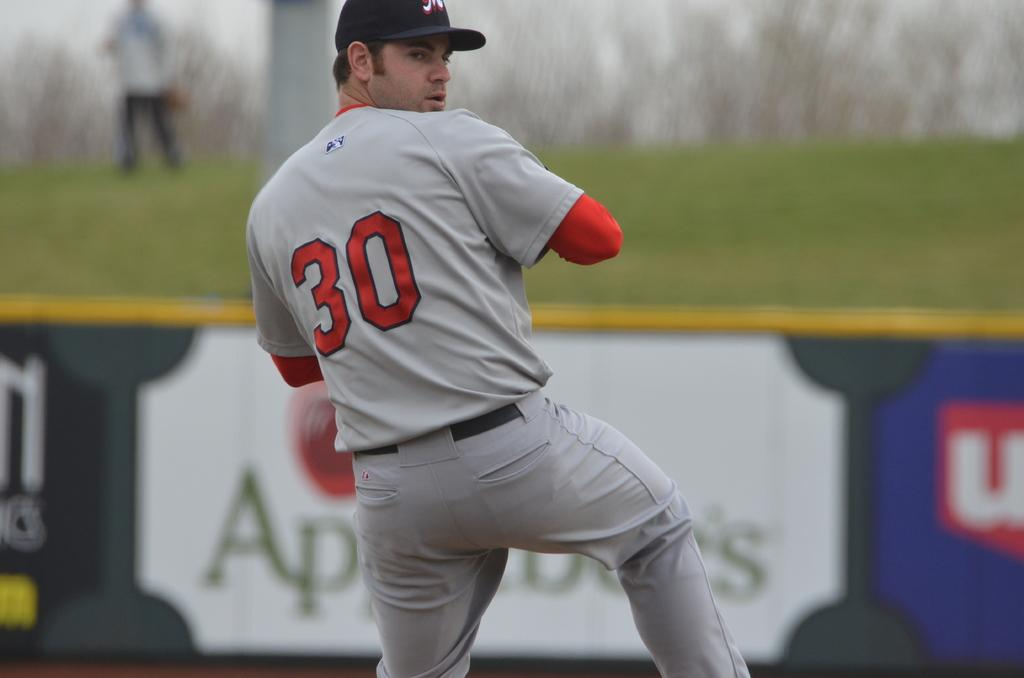<image>
Relay a brief, clear account of the picture shown. Baseball player wearing number 30 about to pitch a ball. 